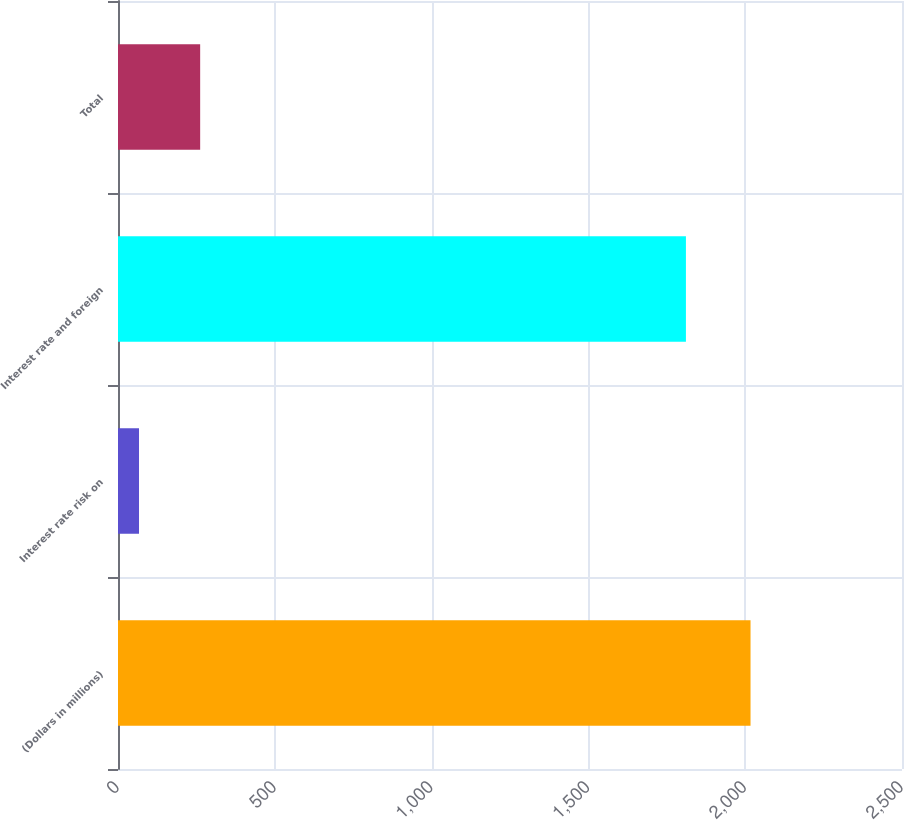Convert chart to OTSL. <chart><loc_0><loc_0><loc_500><loc_500><bar_chart><fcel>(Dollars in millions)<fcel>Interest rate risk on<fcel>Interest rate and foreign<fcel>Total<nl><fcel>2017<fcel>67<fcel>1811<fcel>262<nl></chart> 